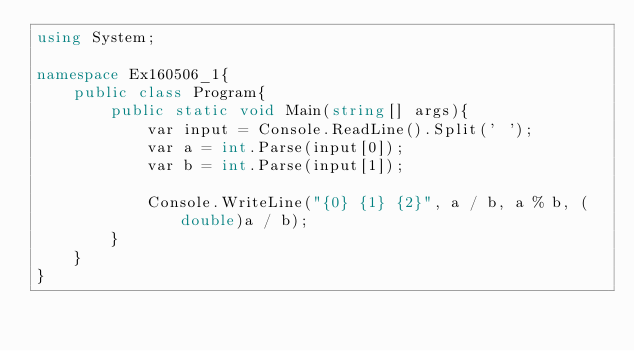Convert code to text. <code><loc_0><loc_0><loc_500><loc_500><_C#_>using System;

namespace Ex160506_1{
    public class Program{
        public static void Main(string[] args){
            var input = Console.ReadLine().Split(' ');
            var a = int.Parse(input[0]);
            var b = int.Parse(input[1]);

            Console.WriteLine("{0} {1} {2}", a / b, a % b, (double)a / b);
        }
    }
}</code> 